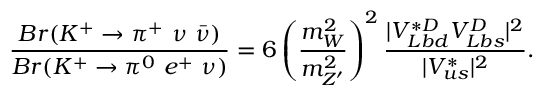<formula> <loc_0><loc_0><loc_500><loc_500>\frac { B r ( K ^ { + } \rightarrow \pi ^ { + } \ \nu \ \bar { \nu } ) } { B r ( K ^ { + } \rightarrow \pi ^ { 0 } \ e ^ { + } \ \nu ) } = 6 \left ( \frac { m _ { W } ^ { 2 } } { m _ { Z ^ { \prime } } ^ { 2 } } \right ) ^ { 2 } \frac { | V _ { L b d } ^ { * D } V _ { L b s } ^ { D } | ^ { 2 } } { | V _ { u s } ^ { * } | ^ { 2 } } .</formula> 